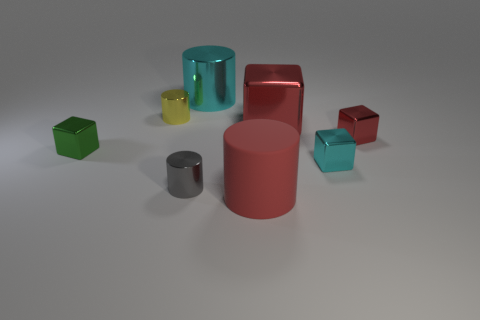Add 1 rubber cylinders. How many objects exist? 9 Subtract all cyan blocks. How many blocks are left? 3 Add 8 tiny yellow shiny cylinders. How many tiny yellow shiny cylinders exist? 9 Subtract all red blocks. How many blocks are left? 2 Subtract 0 blue spheres. How many objects are left? 8 Subtract 2 cubes. How many cubes are left? 2 Subtract all green cubes. Subtract all yellow spheres. How many cubes are left? 3 Subtract all blue balls. How many blue cubes are left? 0 Subtract all small red matte cubes. Subtract all cubes. How many objects are left? 4 Add 2 small metal objects. How many small metal objects are left? 7 